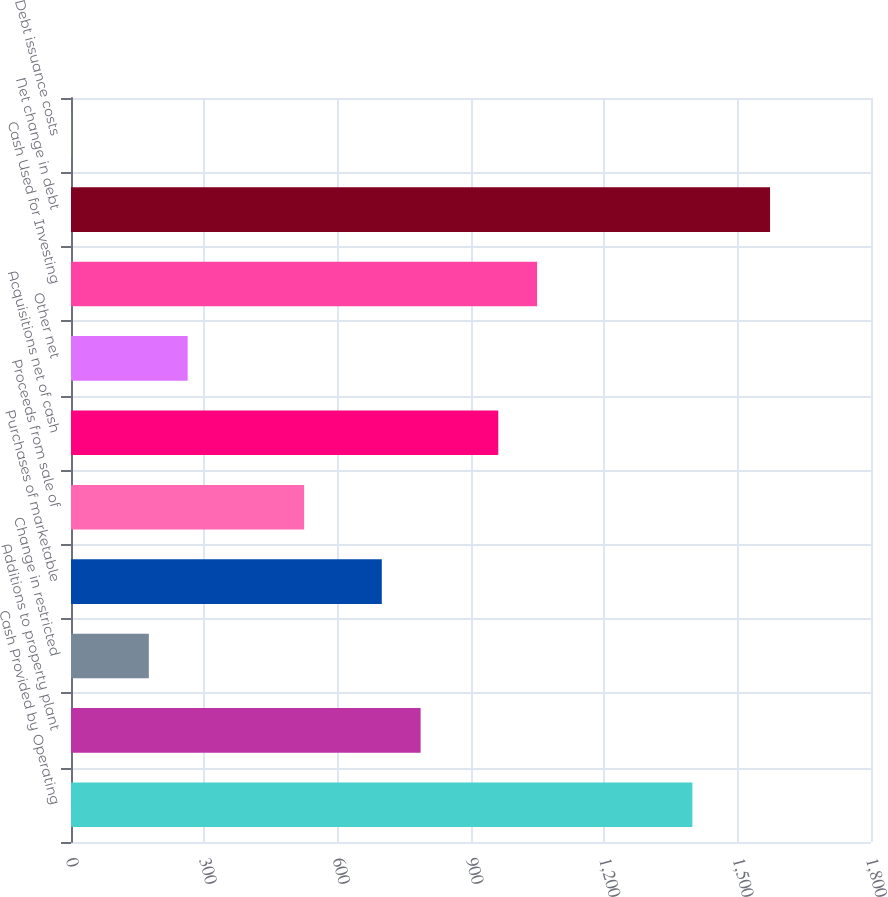<chart> <loc_0><loc_0><loc_500><loc_500><bar_chart><fcel>Cash Provided by Operating<fcel>Additions to property plant<fcel>Change in restricted<fcel>Purchases of marketable<fcel>Proceeds from sale of<fcel>Acquisitions net of cash<fcel>Other net<fcel>Cash Used for Investing<fcel>Net change in debt<fcel>Debt issuance costs<nl><fcel>1398.15<fcel>786.63<fcel>175.11<fcel>699.27<fcel>524.55<fcel>961.35<fcel>262.47<fcel>1048.71<fcel>1572.87<fcel>0.39<nl></chart> 